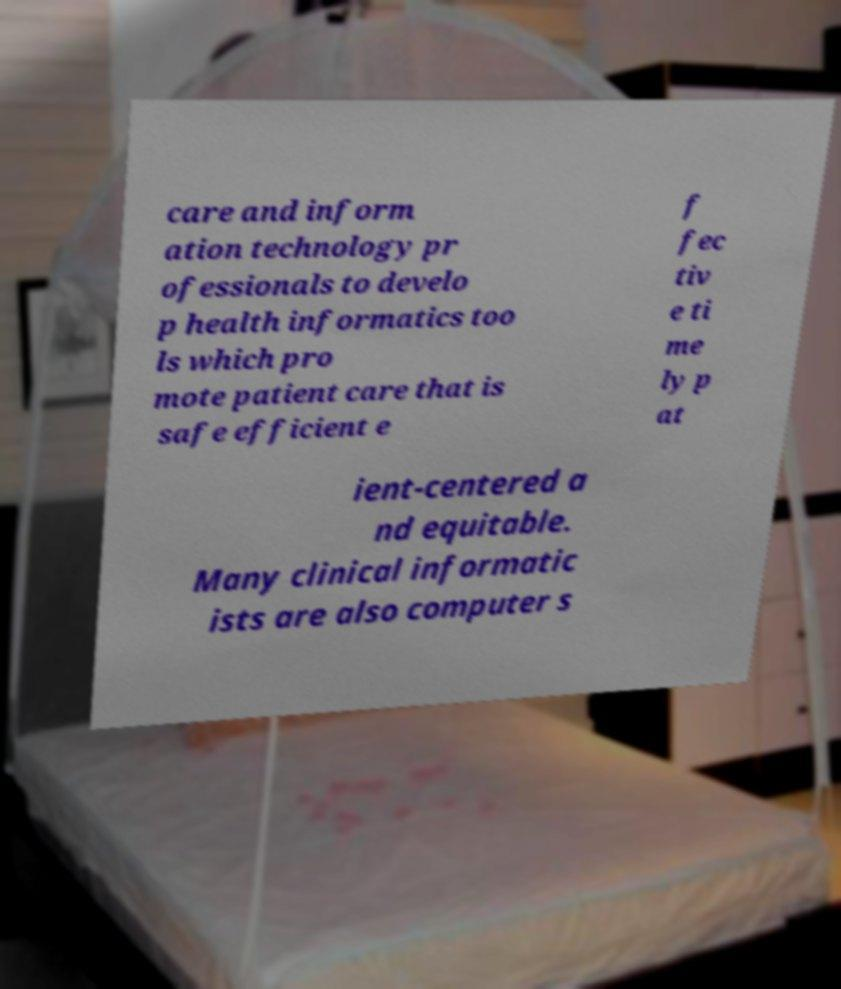Can you accurately transcribe the text from the provided image for me? care and inform ation technology pr ofessionals to develo p health informatics too ls which pro mote patient care that is safe efficient e f fec tiv e ti me ly p at ient-centered a nd equitable. Many clinical informatic ists are also computer s 